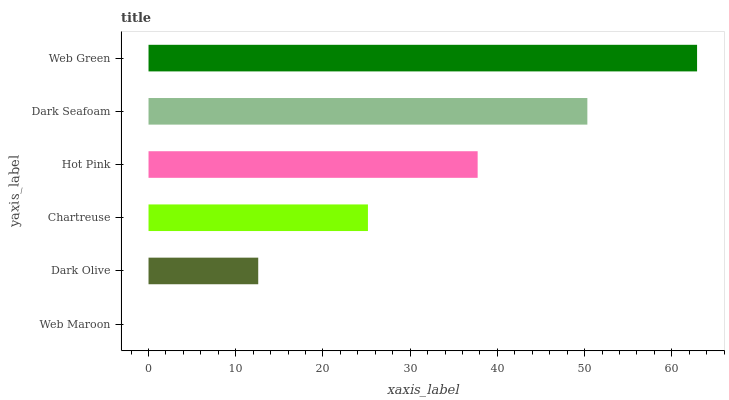Is Web Maroon the minimum?
Answer yes or no. Yes. Is Web Green the maximum?
Answer yes or no. Yes. Is Dark Olive the minimum?
Answer yes or no. No. Is Dark Olive the maximum?
Answer yes or no. No. Is Dark Olive greater than Web Maroon?
Answer yes or no. Yes. Is Web Maroon less than Dark Olive?
Answer yes or no. Yes. Is Web Maroon greater than Dark Olive?
Answer yes or no. No. Is Dark Olive less than Web Maroon?
Answer yes or no. No. Is Hot Pink the high median?
Answer yes or no. Yes. Is Chartreuse the low median?
Answer yes or no. Yes. Is Web Maroon the high median?
Answer yes or no. No. Is Web Maroon the low median?
Answer yes or no. No. 